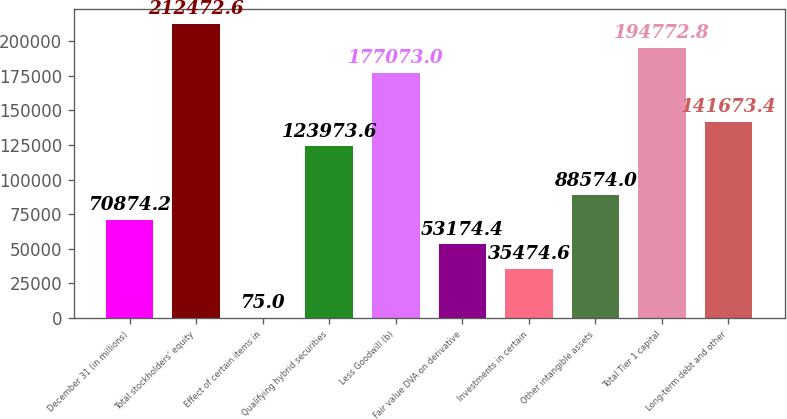Convert chart. <chart><loc_0><loc_0><loc_500><loc_500><bar_chart><fcel>December 31 (in millions)<fcel>Total stockholders' equity<fcel>Effect of certain items in<fcel>Qualifying hybrid securities<fcel>Less Goodwill (b)<fcel>Fair value DVA on derivative<fcel>Investments in certain<fcel>Other intangible assets<fcel>Total Tier 1 capital<fcel>Long-term debt and other<nl><fcel>70874.2<fcel>212473<fcel>75<fcel>123974<fcel>177073<fcel>53174.4<fcel>35474.6<fcel>88574<fcel>194773<fcel>141673<nl></chart> 